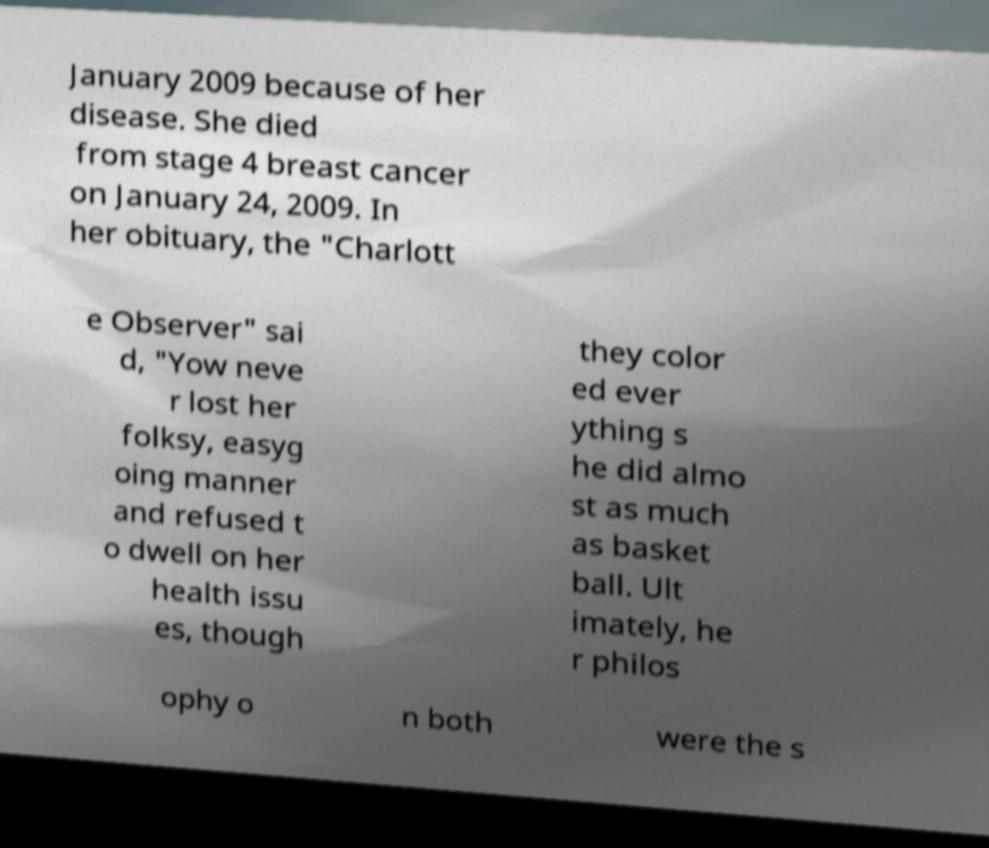I need the written content from this picture converted into text. Can you do that? January 2009 because of her disease. She died from stage 4 breast cancer on January 24, 2009. In her obituary, the "Charlott e Observer" sai d, "Yow neve r lost her folksy, easyg oing manner and refused t o dwell on her health issu es, though they color ed ever ything s he did almo st as much as basket ball. Ult imately, he r philos ophy o n both were the s 